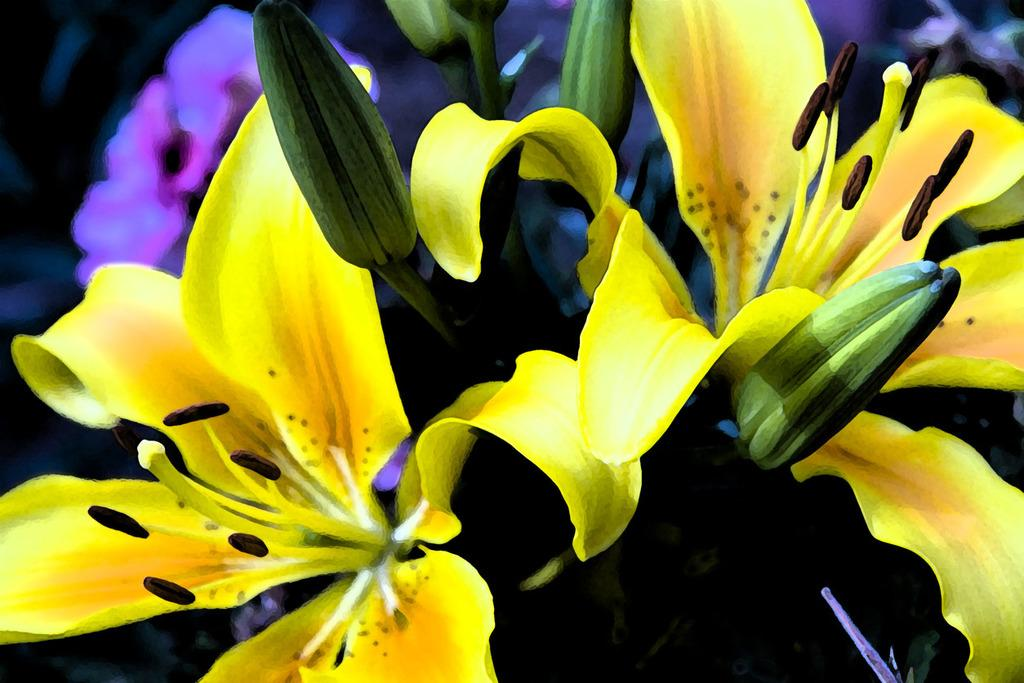What type of plants are in the image? The image contains flowers. Can you describe the flowers in the foreground? There are yellow flowers in the foreground. What is the color of the buds in the foreground? There are green buds in the foreground. How many bears can be seen on the island in the image? There is no island or bears present in the image; it features flowers and buds. 